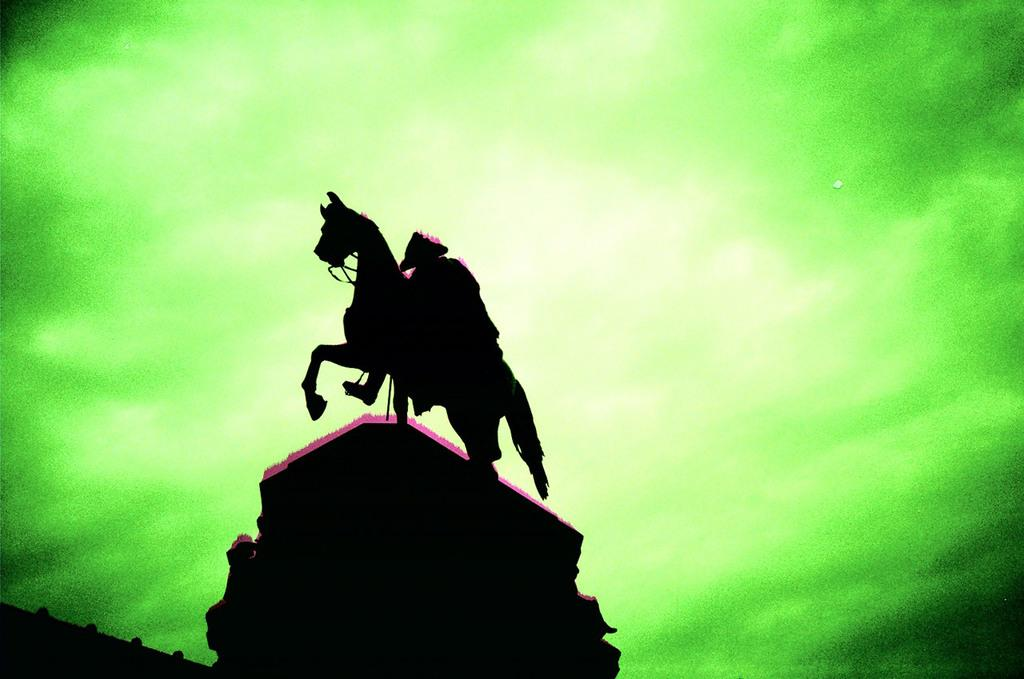What is the main subject in the image? There is a sculpture in the image. What color is the background of the image? The background of the image is green. Can you see any pipes or faucets connected to the sculpture in the image? There is no mention of pipes or faucets in the provided facts, and therefore it cannot be determined if they are present in the image. 